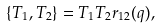<formula> <loc_0><loc_0><loc_500><loc_500>\{ T _ { 1 } , T _ { 2 } \} = T _ { 1 } T _ { 2 } r _ { 1 2 } ( q ) ,</formula> 